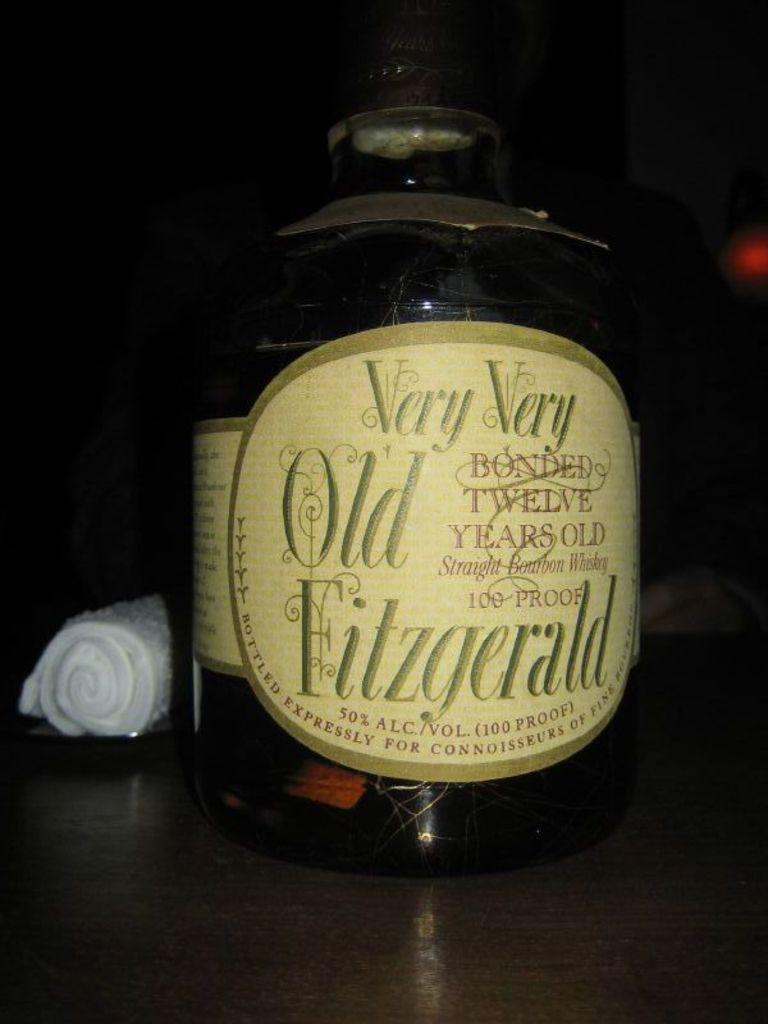How old is the fitzgerald?
Provide a short and direct response. Twelve. What is the name of this beverage?
Keep it short and to the point. Very very old fitzgerald. 